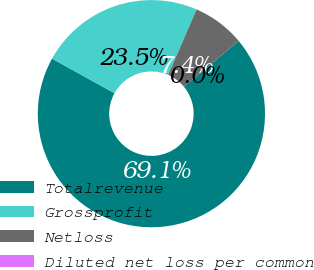Convert chart. <chart><loc_0><loc_0><loc_500><loc_500><pie_chart><fcel>Totalrevenue<fcel>Grossprofit<fcel>Netloss<fcel>Diluted net loss per common<nl><fcel>69.1%<fcel>23.46%<fcel>7.44%<fcel>0.0%<nl></chart> 